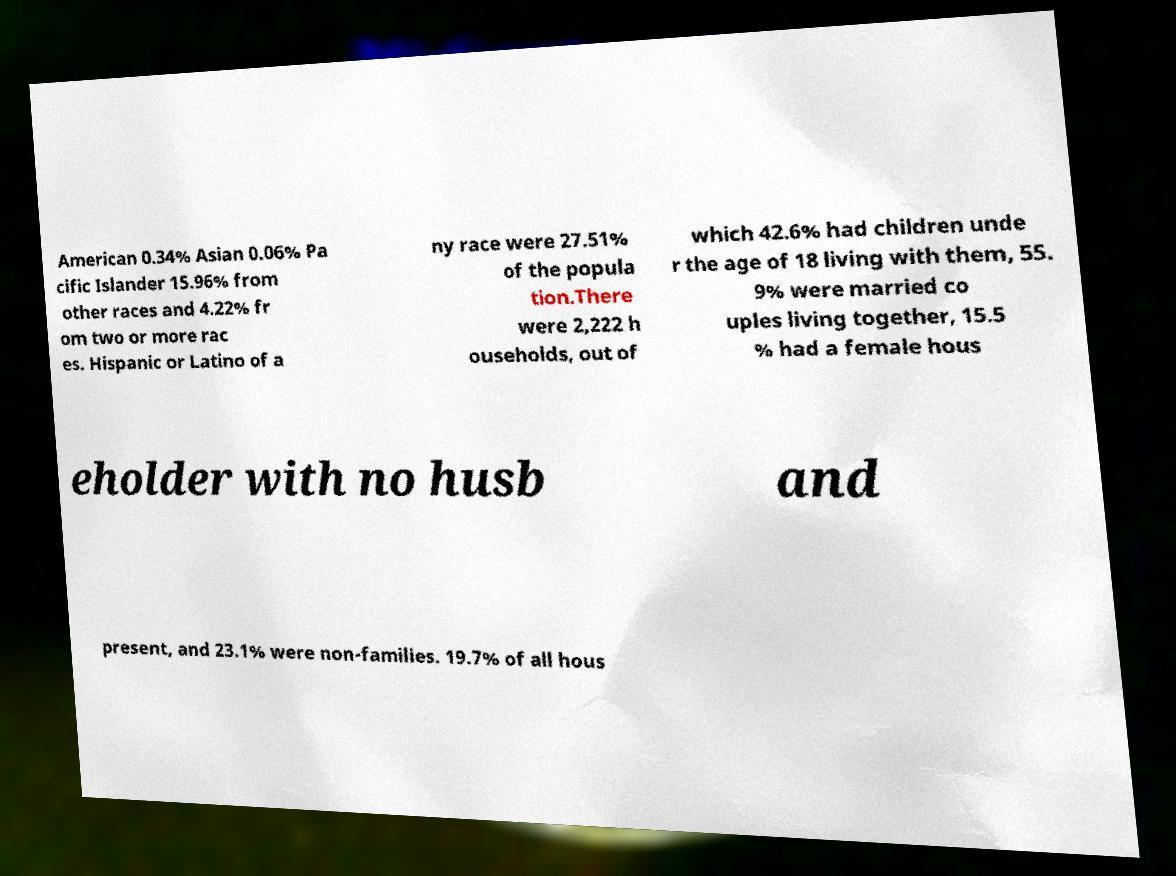Can you read and provide the text displayed in the image?This photo seems to have some interesting text. Can you extract and type it out for me? American 0.34% Asian 0.06% Pa cific Islander 15.96% from other races and 4.22% fr om two or more rac es. Hispanic or Latino of a ny race were 27.51% of the popula tion.There were 2,222 h ouseholds, out of which 42.6% had children unde r the age of 18 living with them, 55. 9% were married co uples living together, 15.5 % had a female hous eholder with no husb and present, and 23.1% were non-families. 19.7% of all hous 